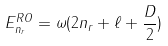Convert formula to latex. <formula><loc_0><loc_0><loc_500><loc_500>E _ { n _ { r } } ^ { R O } = \omega ( 2 n _ { r } + \ell + \frac { D } { 2 } )</formula> 